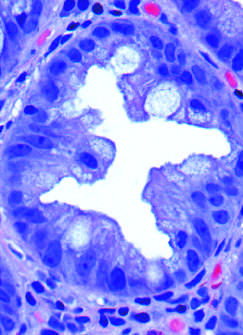does epithelial crowding produce a serrated architecture when glands are cut in cross-section?
Answer the question using a single word or phrase. Yes 